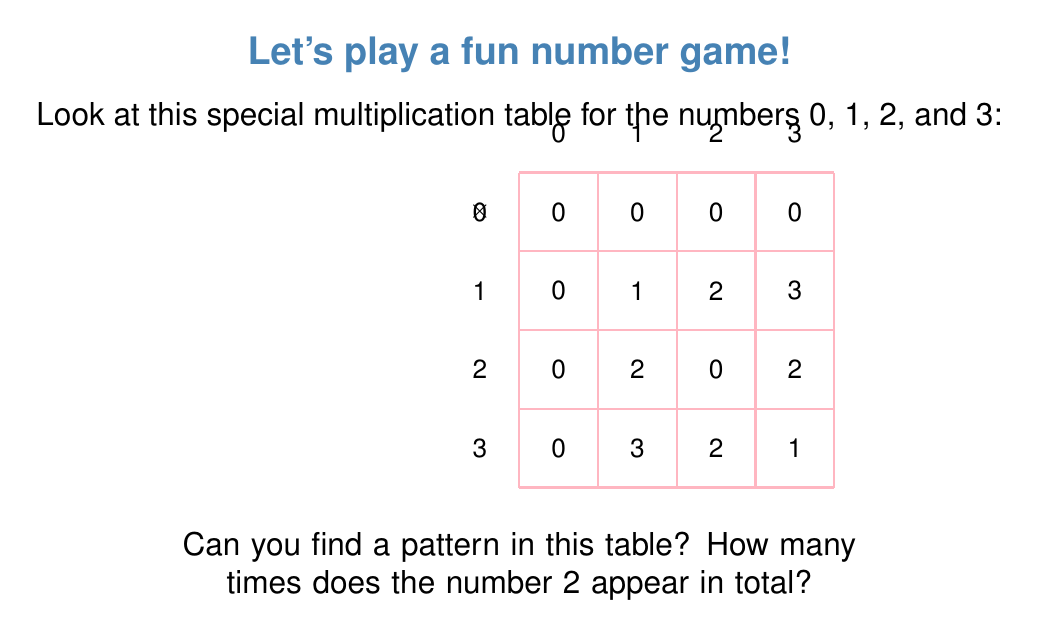Give your solution to this math problem. Let's count the number of times 2 appears in the table:

1. First row: No 2's
2. Second row: One 2 (1 × 2 = 2)
3. Third row: Two 2's (2 × 1 = 2 and 2 × 3 = 2)
4. Fourth row: One 2 (3 × 2 = 2)

To find the total, we add these up:
$$ 0 + 1 + 2 + 1 = 4 $$

So, the number 2 appears 4 times in total.

The pattern we can observe is that 2 appears:
- When multiplying any number by 2 (except 0)
- When multiplying 3 by 3

This special multiplication table is actually for a mathematical structure called a "ring," specifically the ring of integers modulo 4, often written as $\mathbb{Z}_4$.
Answer: 4 